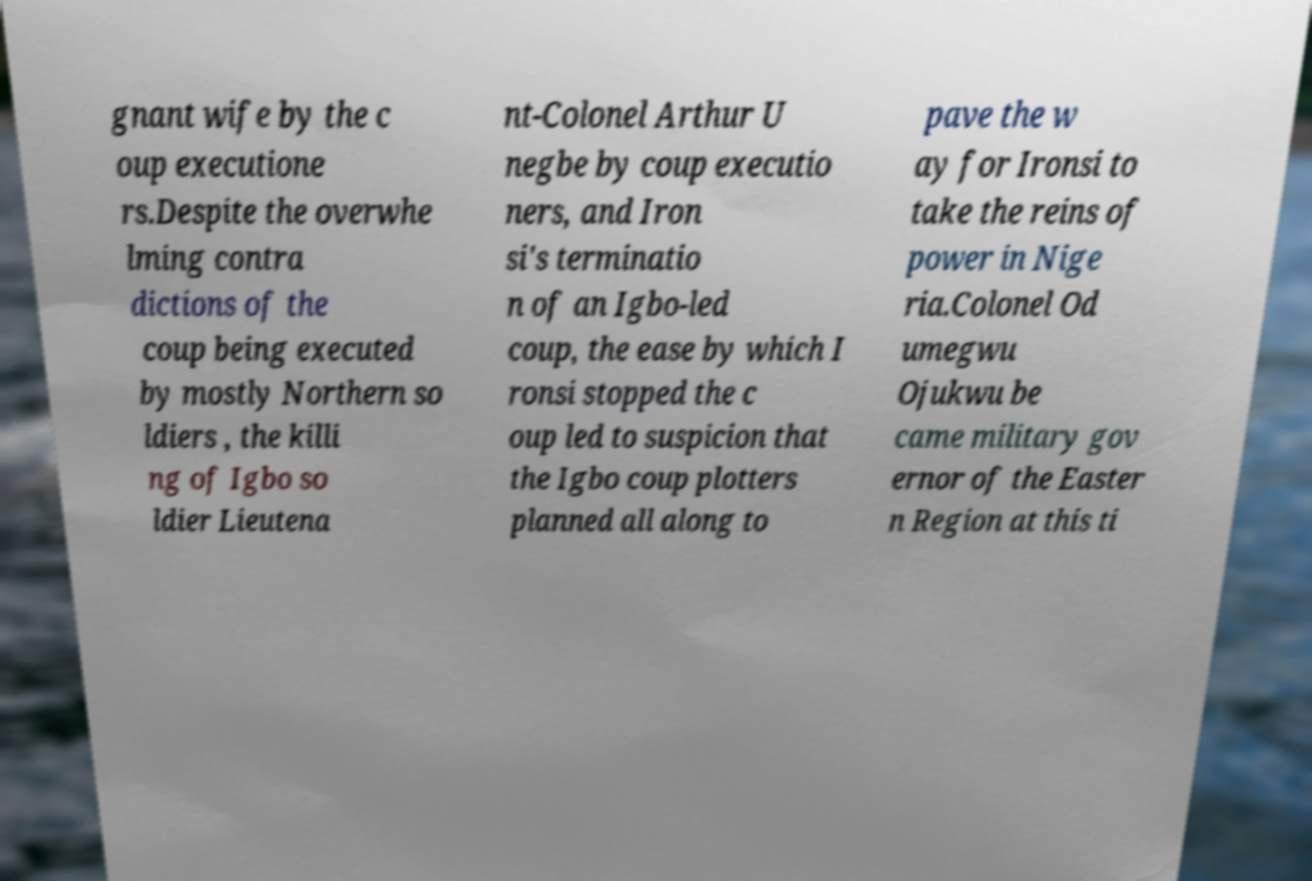Could you assist in decoding the text presented in this image and type it out clearly? gnant wife by the c oup executione rs.Despite the overwhe lming contra dictions of the coup being executed by mostly Northern so ldiers , the killi ng of Igbo so ldier Lieutena nt-Colonel Arthur U negbe by coup executio ners, and Iron si's terminatio n of an Igbo-led coup, the ease by which I ronsi stopped the c oup led to suspicion that the Igbo coup plotters planned all along to pave the w ay for Ironsi to take the reins of power in Nige ria.Colonel Od umegwu Ojukwu be came military gov ernor of the Easter n Region at this ti 